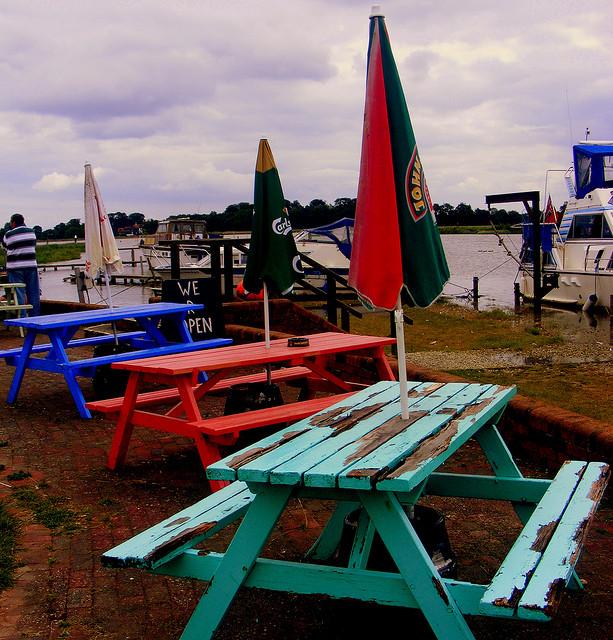What are the benches used for?
Concise answer only. Eating. What colors are the tables?
Answer briefly. Green red and blue. Where are the boats?
Answer briefly. In water. 